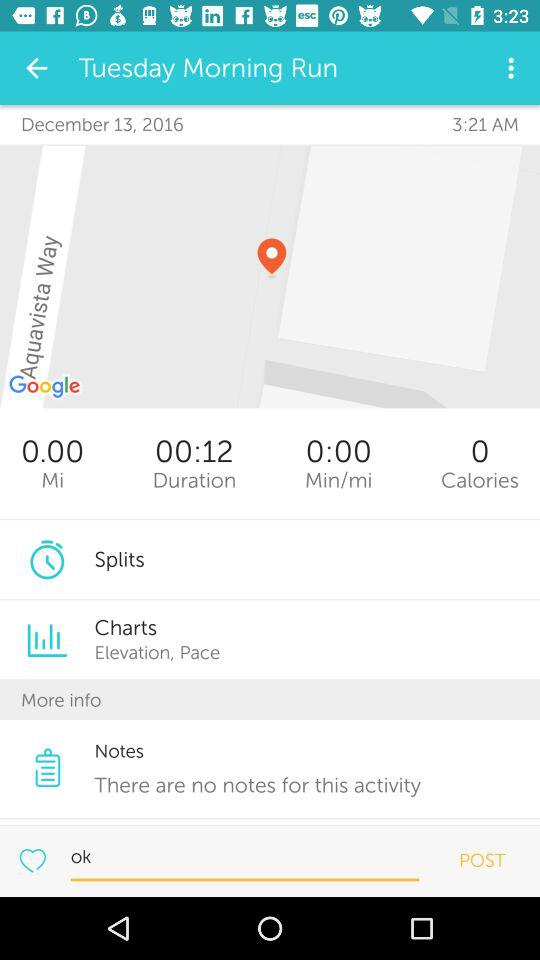How many calories did the user burn?
Answer the question using a single word or phrase. 0 